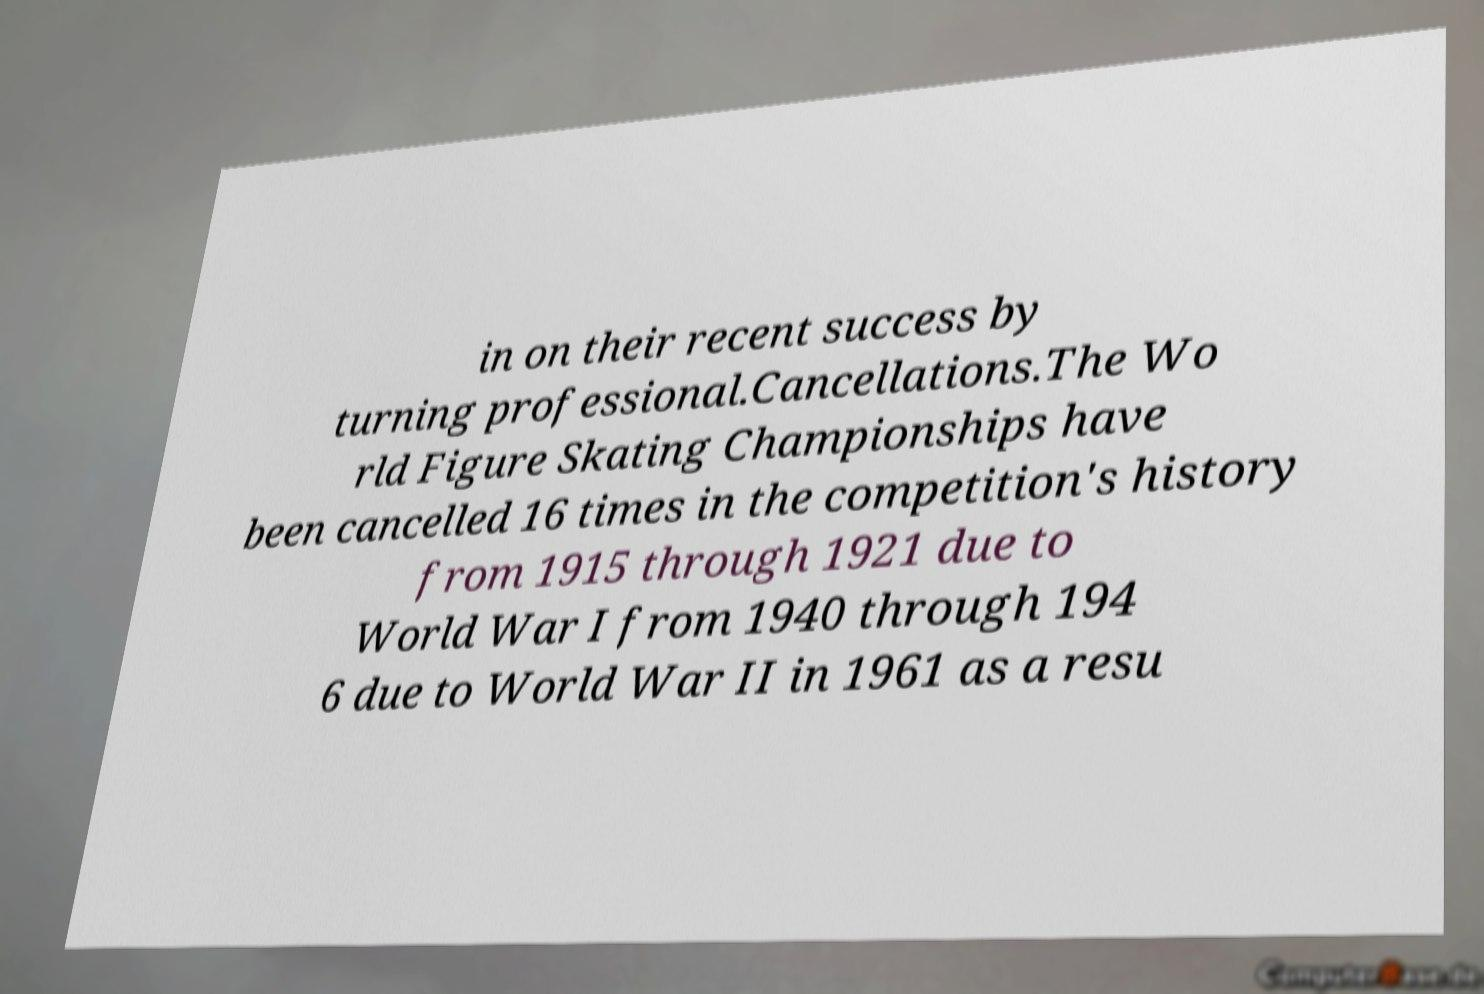Please read and relay the text visible in this image. What does it say? in on their recent success by turning professional.Cancellations.The Wo rld Figure Skating Championships have been cancelled 16 times in the competition's history from 1915 through 1921 due to World War I from 1940 through 194 6 due to World War II in 1961 as a resu 